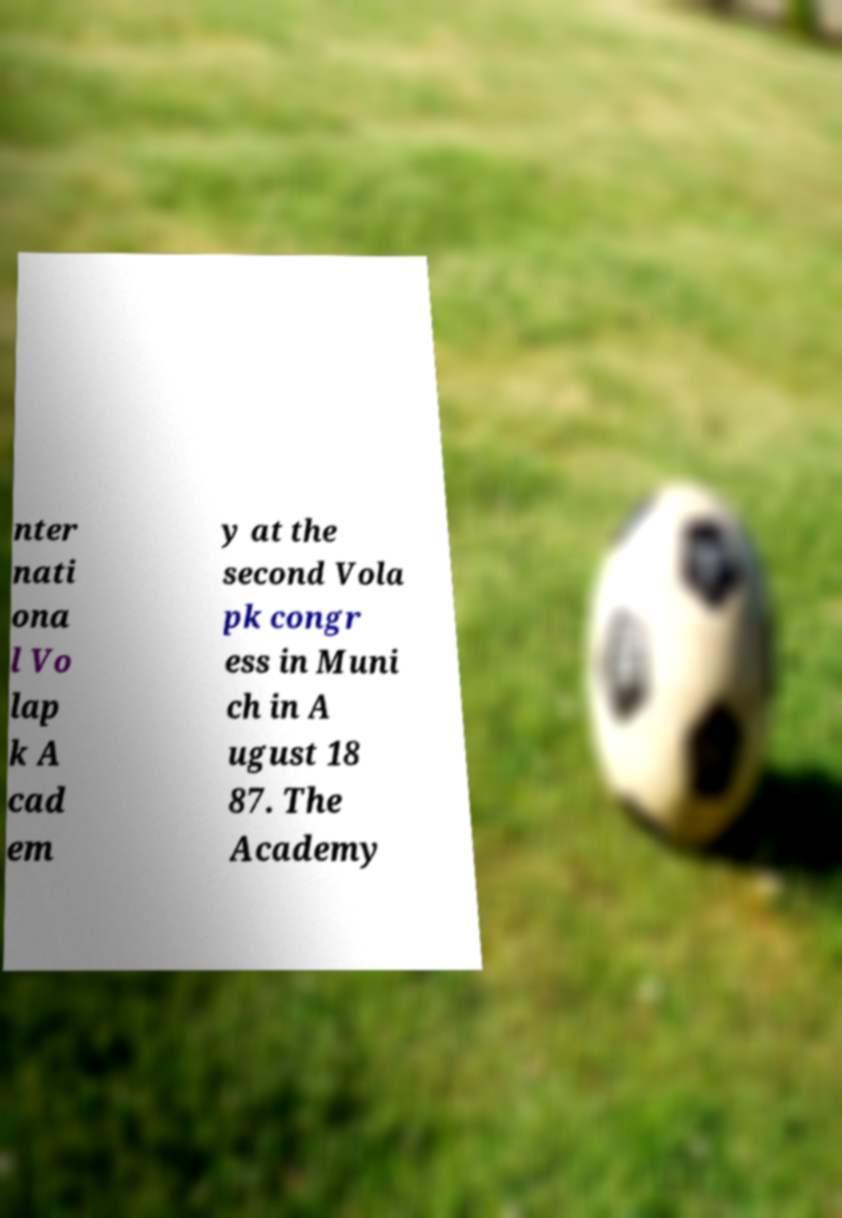Could you assist in decoding the text presented in this image and type it out clearly? nter nati ona l Vo lap k A cad em y at the second Vola pk congr ess in Muni ch in A ugust 18 87. The Academy 